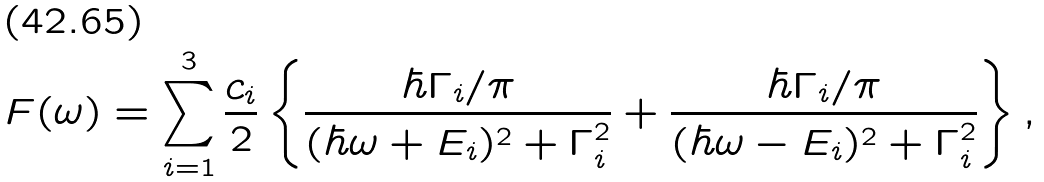Convert formula to latex. <formula><loc_0><loc_0><loc_500><loc_500>F ( \omega ) = \sum _ { i = 1 } ^ { 3 } \frac { c _ { i } } { 2 } \left \{ \frac { \hbar { \Gamma } _ { i } / \pi } { ( \hbar { \omega } + E _ { i } ) ^ { 2 } + \Gamma _ { i } ^ { 2 } } + \frac { \hbar { \Gamma } _ { i } / \pi } { ( \hbar { \omega } - E _ { i } ) ^ { 2 } + \Gamma _ { i } ^ { 2 } } \right \} ,</formula> 